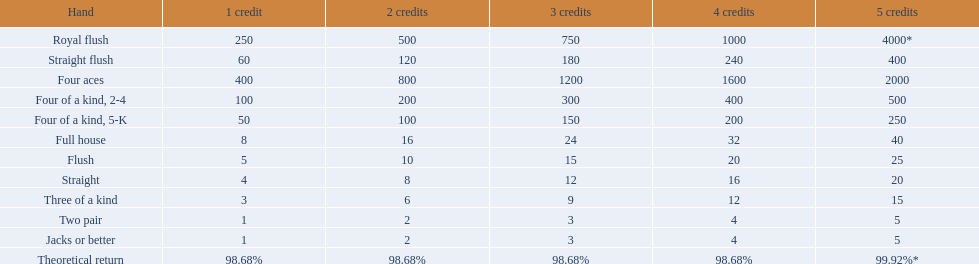What are the hands in super aces? Royal flush, Straight flush, Four aces, Four of a kind, 2-4, Four of a kind, 5-K, Full house, Flush, Straight, Three of a kind, Two pair, Jacks or better. Which hand provides the maximum credits? Royal flush. 